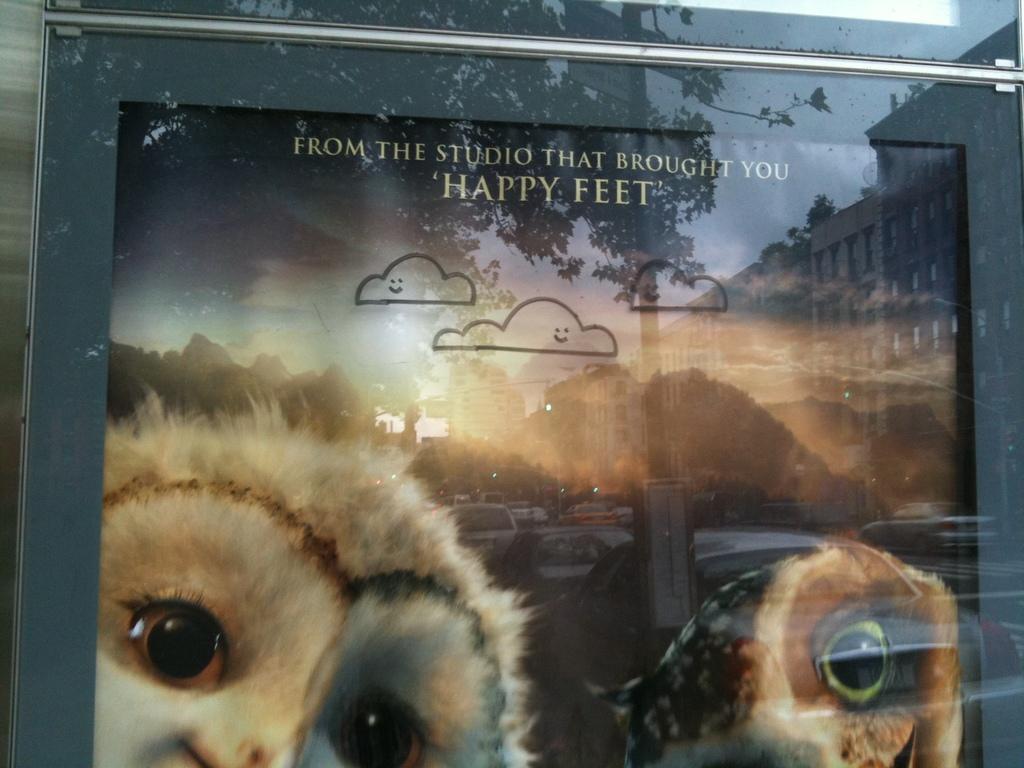How would you summarize this image in a sentence or two? In this picture, we see a photo frame or a board in grey color. This might be the photo frame of the animals. We see the reflections of trees, buildings, pole, sky and the cars in the glass. We see the cars are moving on the road. 